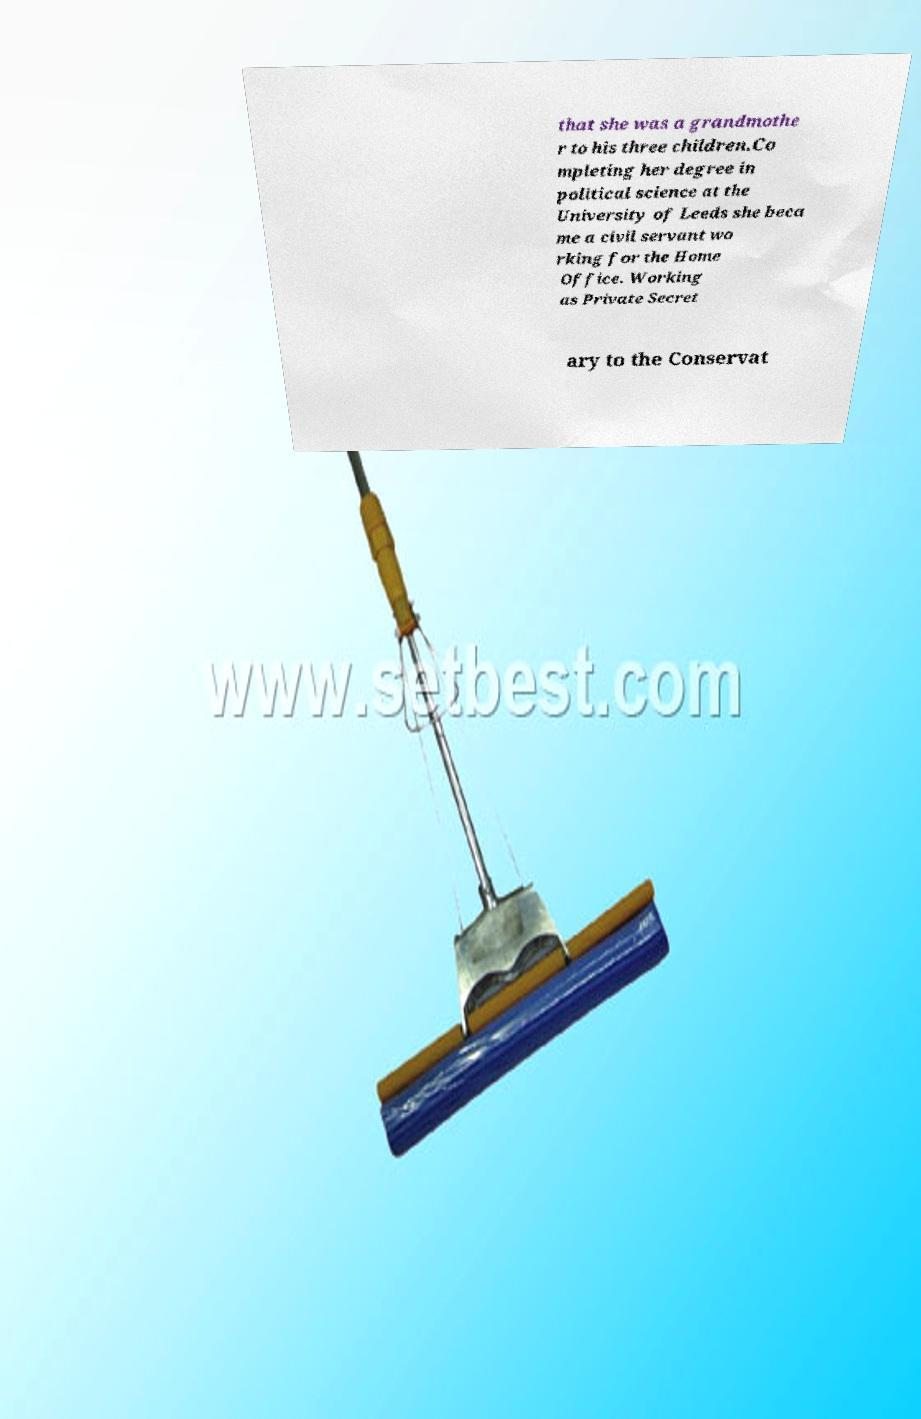For documentation purposes, I need the text within this image transcribed. Could you provide that? that she was a grandmothe r to his three children.Co mpleting her degree in political science at the University of Leeds she beca me a civil servant wo rking for the Home Office. Working as Private Secret ary to the Conservat 